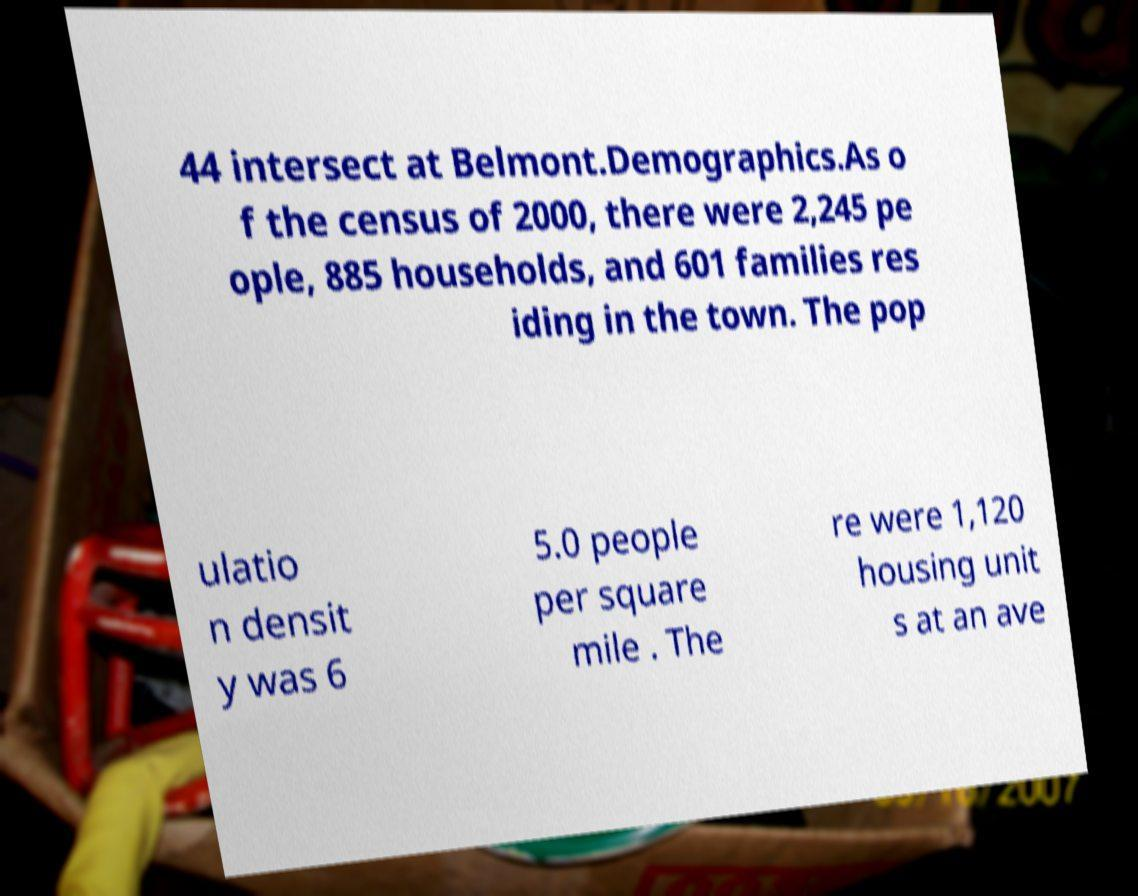Can you accurately transcribe the text from the provided image for me? 44 intersect at Belmont.Demographics.As o f the census of 2000, there were 2,245 pe ople, 885 households, and 601 families res iding in the town. The pop ulatio n densit y was 6 5.0 people per square mile . The re were 1,120 housing unit s at an ave 